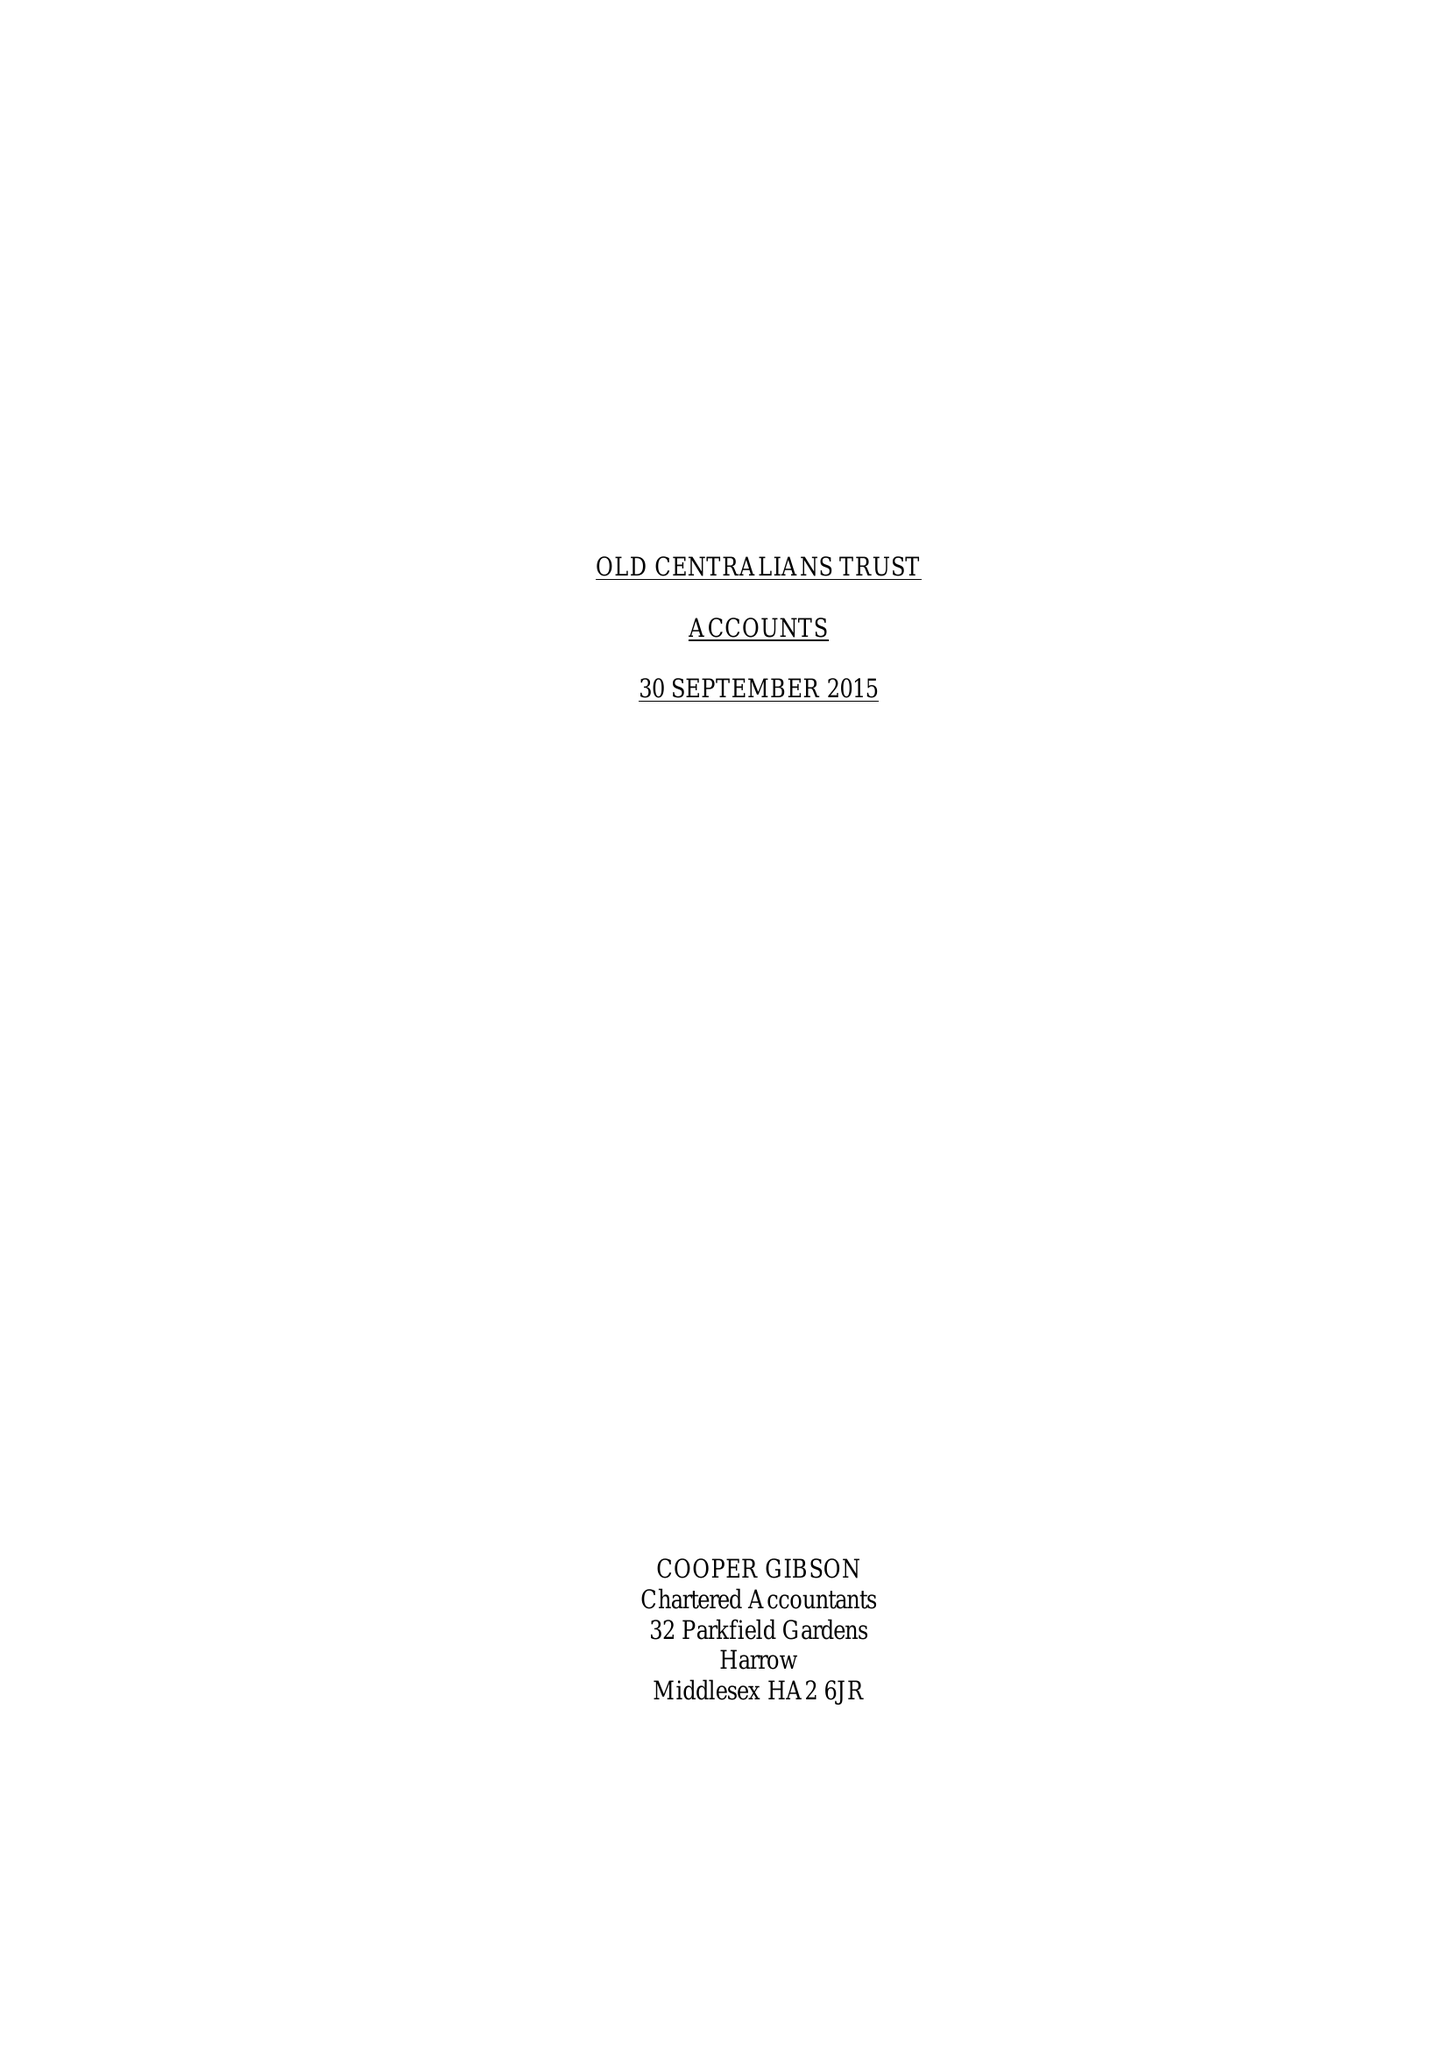What is the value for the charity_number?
Answer the question using a single word or phrase. 1048552 